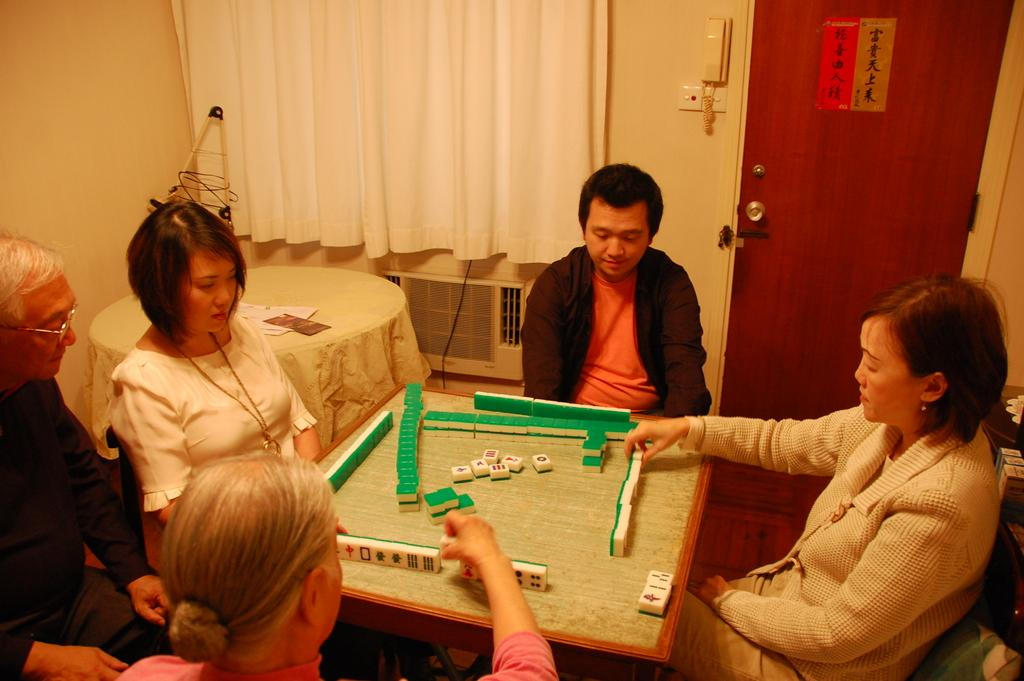What activity are the people in the image engaged in? The people in the image are playing a game with cubes. What can be seen in the background of the image? There is a curtain, a table, a door, and a telephone in the background of the image. What type of tomatoes are being used as part of the game in the image? There are no tomatoes present in the image; the game involves cubes. What kind of music can be heard playing in the background of the image? There is no music present in the image; the focus is on the game with cubes and the background elements. 